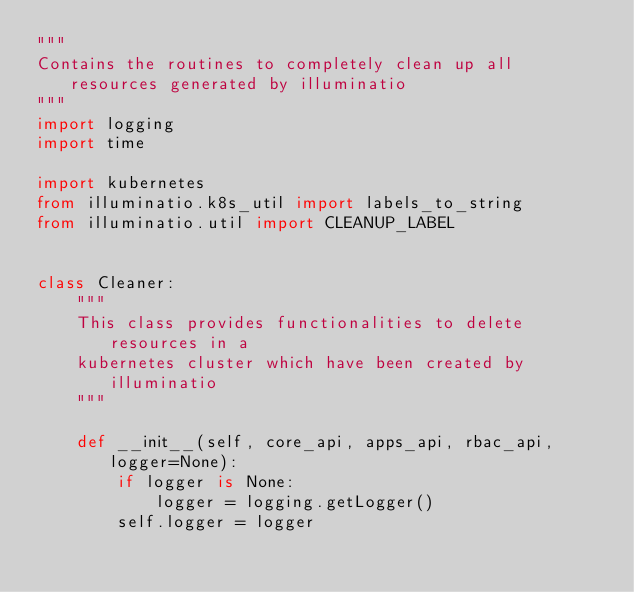<code> <loc_0><loc_0><loc_500><loc_500><_Python_>"""
Contains the routines to completely clean up all resources generated by illuminatio
"""
import logging
import time

import kubernetes
from illuminatio.k8s_util import labels_to_string
from illuminatio.util import CLEANUP_LABEL


class Cleaner:
    """
    This class provides functionalities to delete resources in a
    kubernetes cluster which have been created by illuminatio
    """

    def __init__(self, core_api, apps_api, rbac_api, logger=None):
        if logger is None:
            logger = logging.getLogger()
        self.logger = logger</code> 